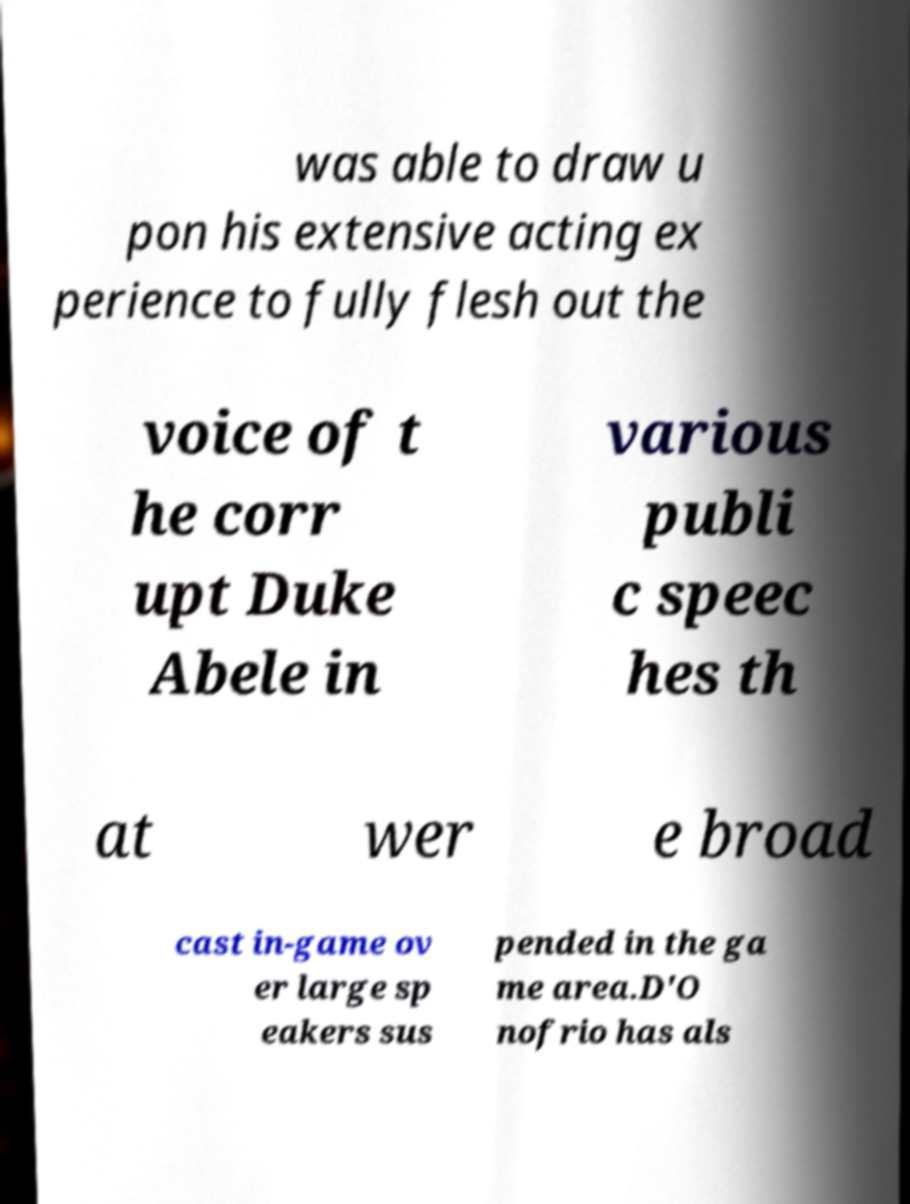Please read and relay the text visible in this image. What does it say? was able to draw u pon his extensive acting ex perience to fully flesh out the voice of t he corr upt Duke Abele in various publi c speec hes th at wer e broad cast in-game ov er large sp eakers sus pended in the ga me area.D'O nofrio has als 